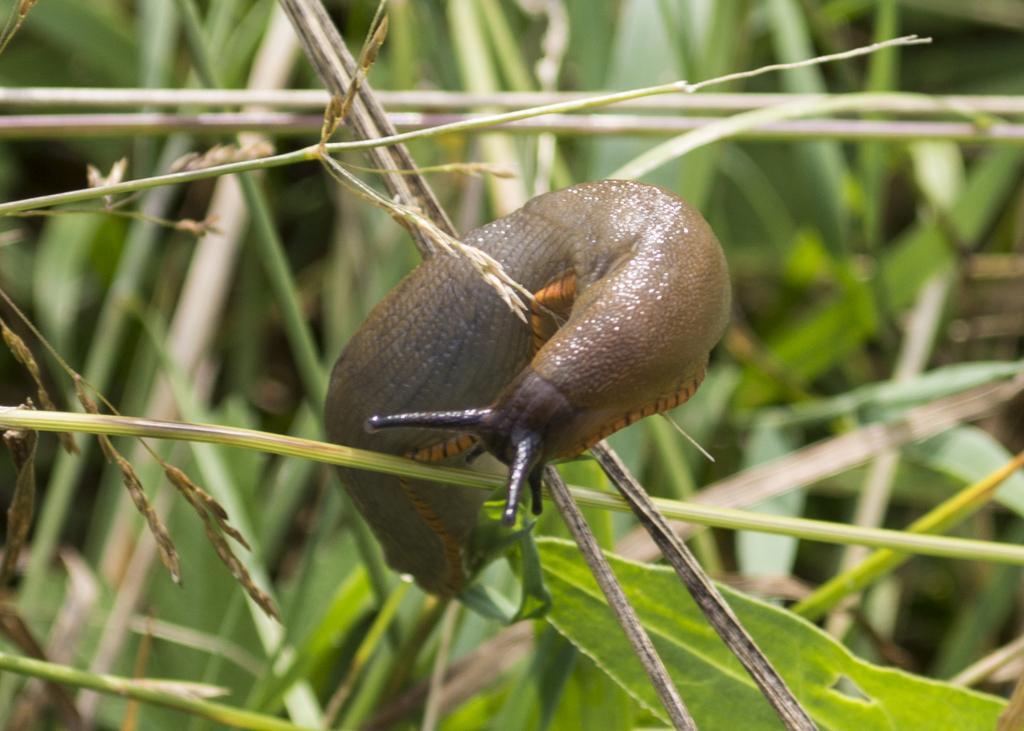Describe this image in one or two sentences. In the picture I can see the snail animal. I can see the green grass and there are green leaves at the bottom of the picture. 